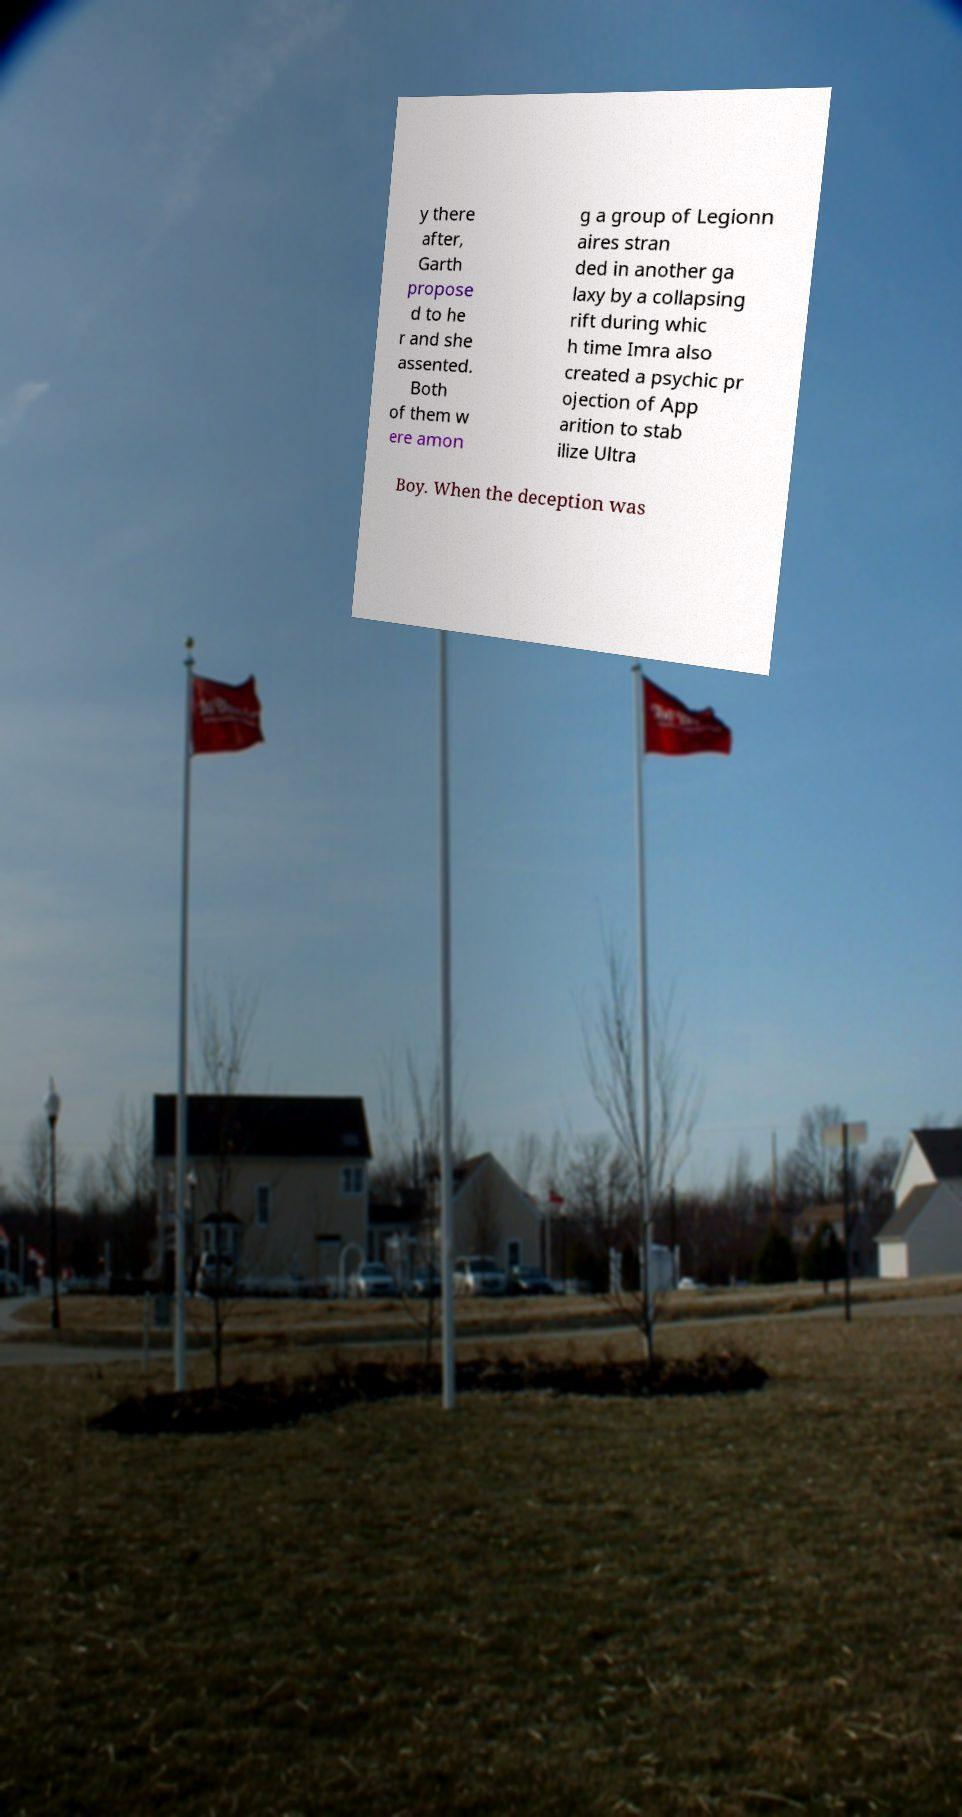Can you accurately transcribe the text from the provided image for me? y there after, Garth propose d to he r and she assented. Both of them w ere amon g a group of Legionn aires stran ded in another ga laxy by a collapsing rift during whic h time Imra also created a psychic pr ojection of App arition to stab ilize Ultra Boy. When the deception was 